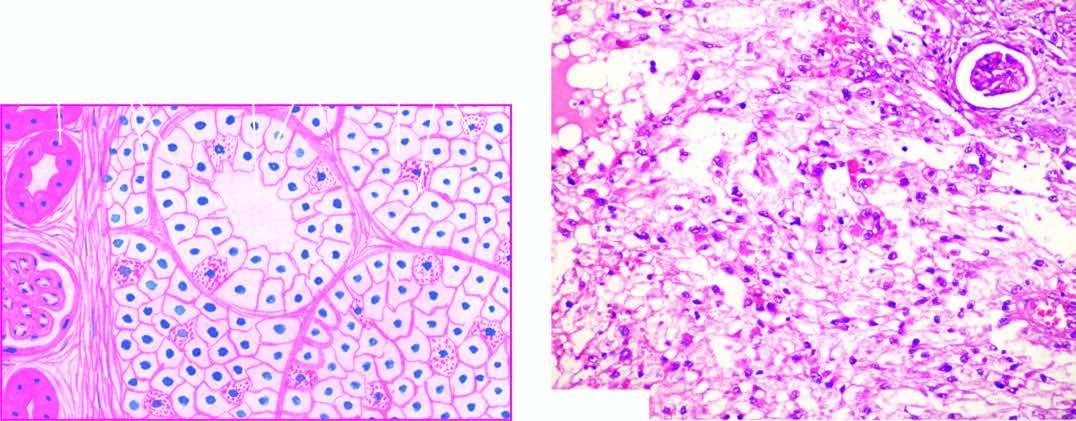does the peripheral zone show solid masses and acini of uniform-appearing tumour cells?
Answer the question using a single word or phrase. No 